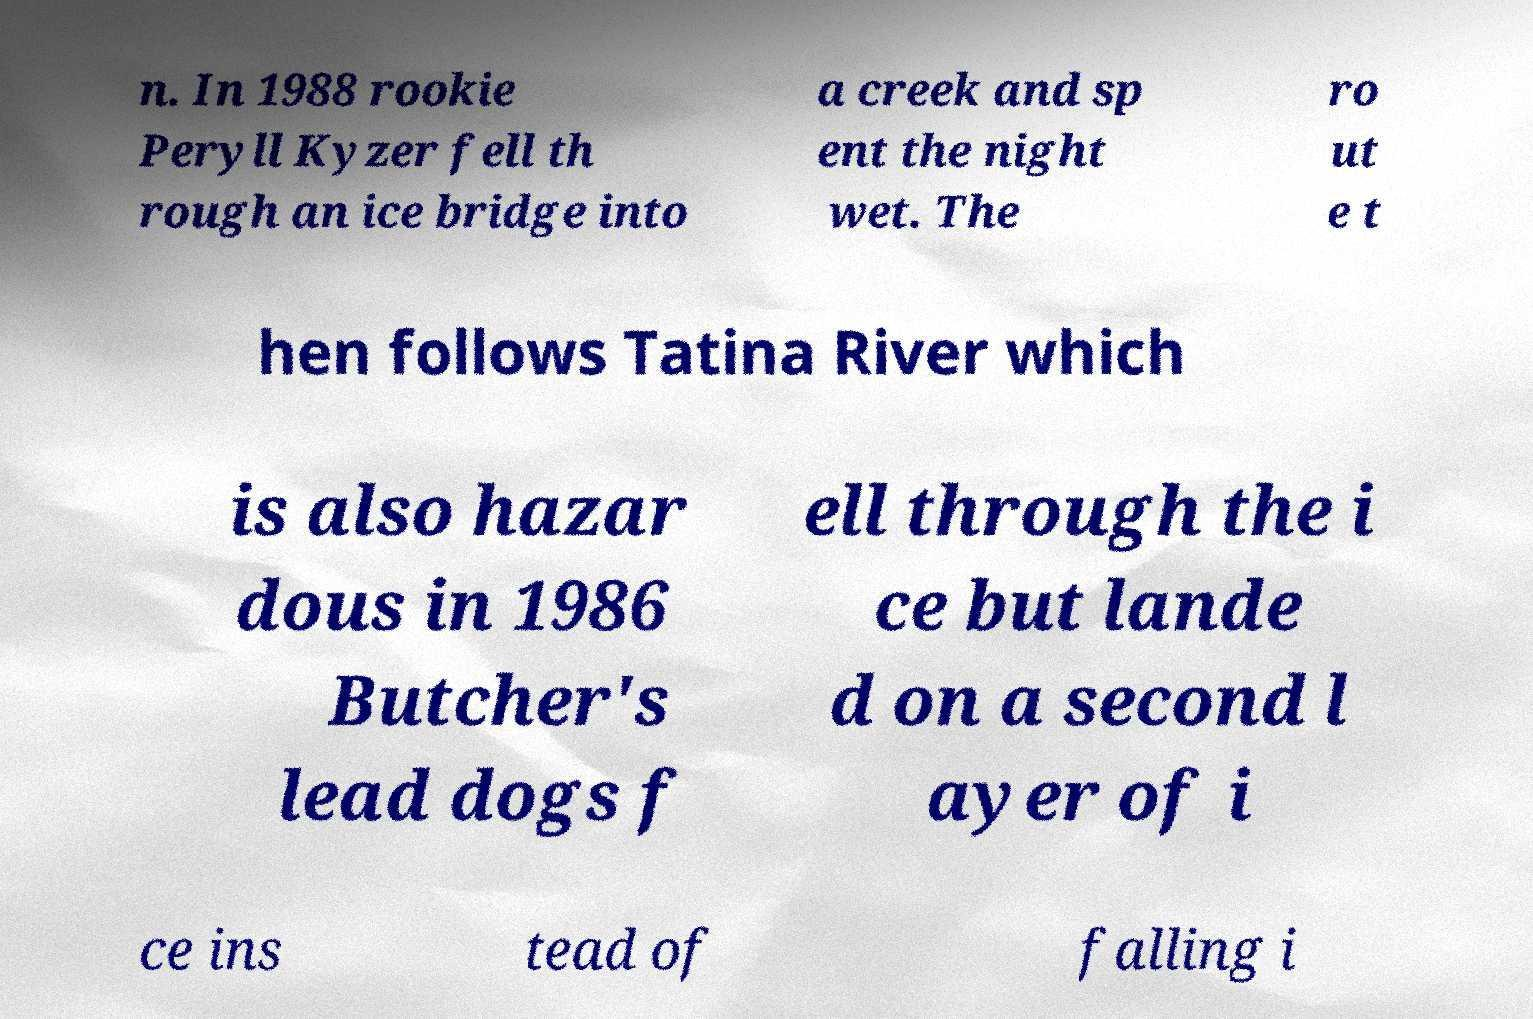Please read and relay the text visible in this image. What does it say? n. In 1988 rookie Peryll Kyzer fell th rough an ice bridge into a creek and sp ent the night wet. The ro ut e t hen follows Tatina River which is also hazar dous in 1986 Butcher's lead dogs f ell through the i ce but lande d on a second l ayer of i ce ins tead of falling i 